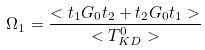<formula> <loc_0><loc_0><loc_500><loc_500>\Omega _ { 1 } = \frac { < t _ { 1 } G _ { 0 } t _ { 2 } + t _ { 2 } G _ { 0 } t _ { 1 } > } { < T ^ { 0 } _ { K D } > }</formula> 